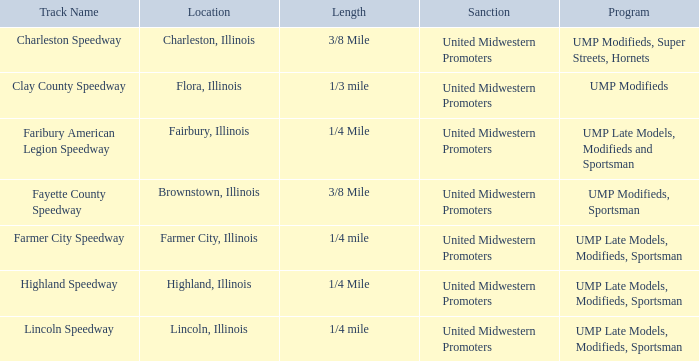In which place is farmer city speedway situated? Farmer City, Illinois. 